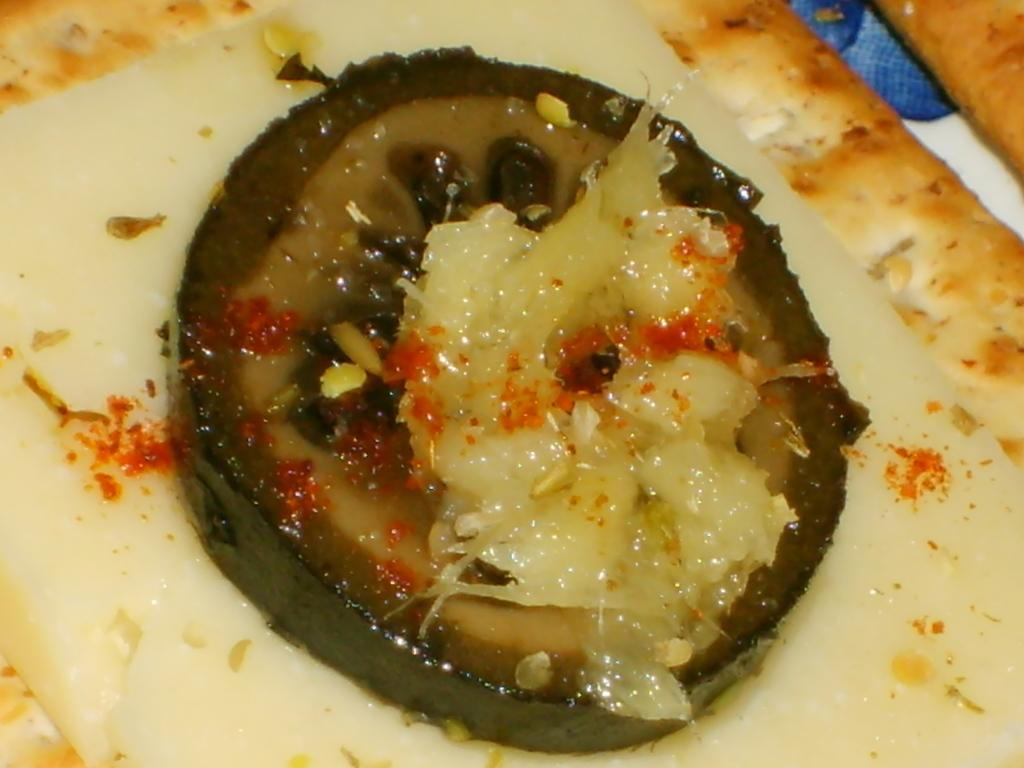What is the main subject of the image? There is a food item in the image. Can you describe the food item in more detail? The food item has ingredients on it. What type of creature is sailing on the food item in the image? There is no creature sailing on the food item in the image. 